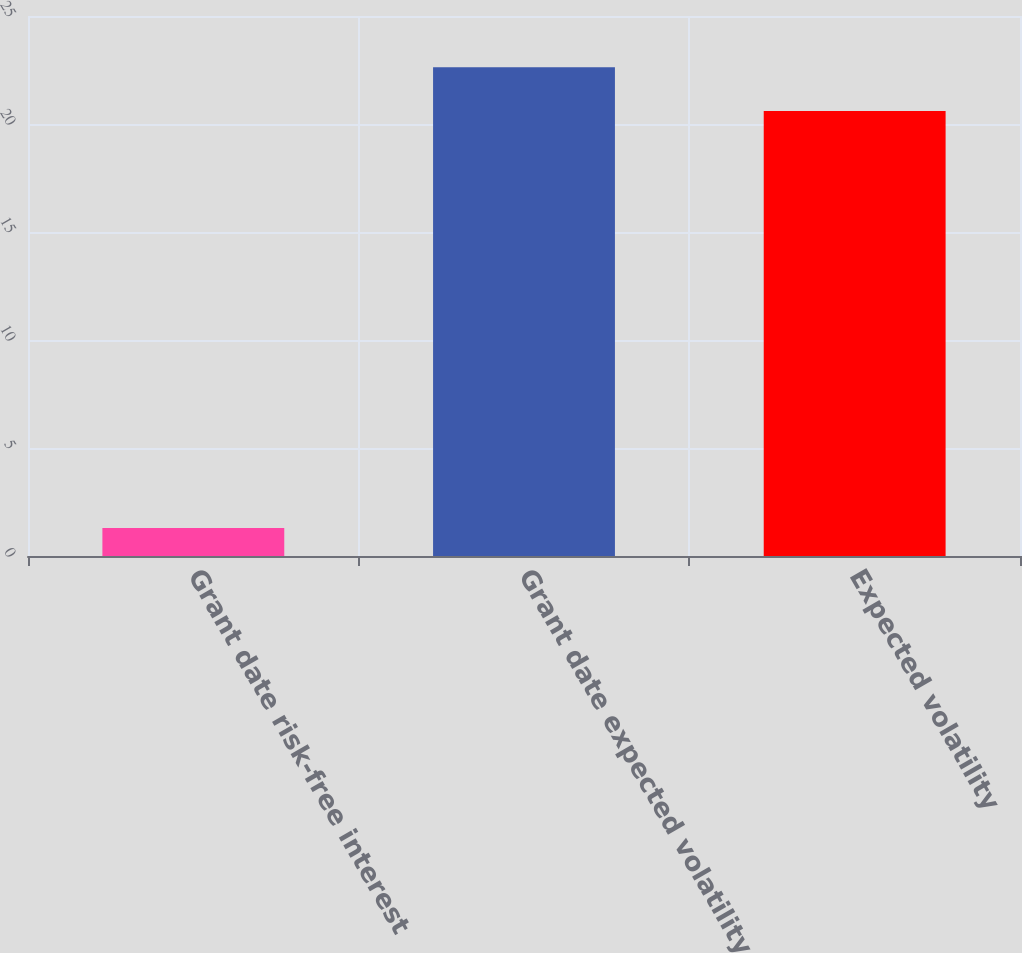Convert chart to OTSL. <chart><loc_0><loc_0><loc_500><loc_500><bar_chart><fcel>Grant date risk-free interest<fcel>Grant date expected volatility<fcel>Expected volatility<nl><fcel>1.3<fcel>22.63<fcel>20.6<nl></chart> 